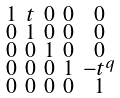<formula> <loc_0><loc_0><loc_500><loc_500>\begin{smallmatrix} 1 & t & 0 & 0 & 0 \\ 0 & 1 & 0 & 0 & 0 \\ 0 & 0 & 1 & 0 & 0 \\ 0 & 0 & 0 & 1 & - t ^ { q } \\ 0 & 0 & 0 & 0 & 1 \end{smallmatrix}</formula> 